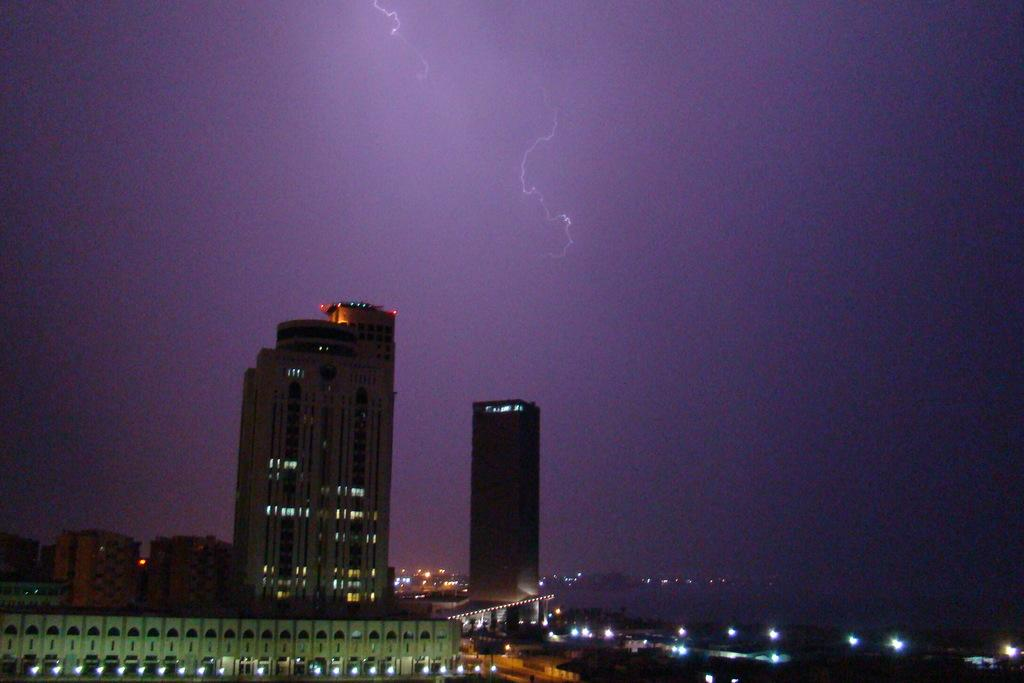What structures can be seen in the image? There are buildings in the image. What part of the natural environment is visible in the image? The sky is visible in the background of the image. Is there an ornament hanging from the buildings in the image? There is no mention of an ornament in the image, so it cannot be determined if one is present. 